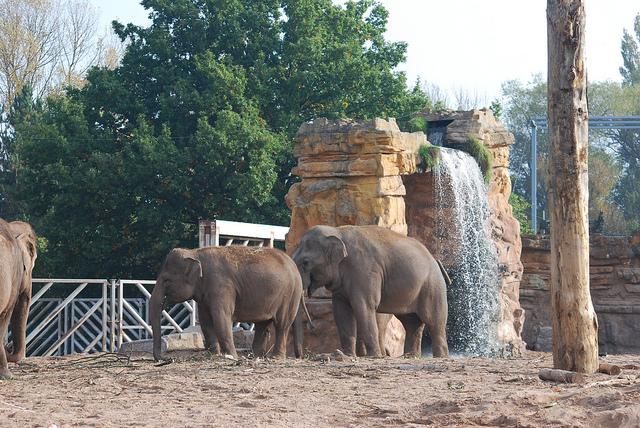What is near the elephants? Please explain your reasoning. trees. There are trees near them. 